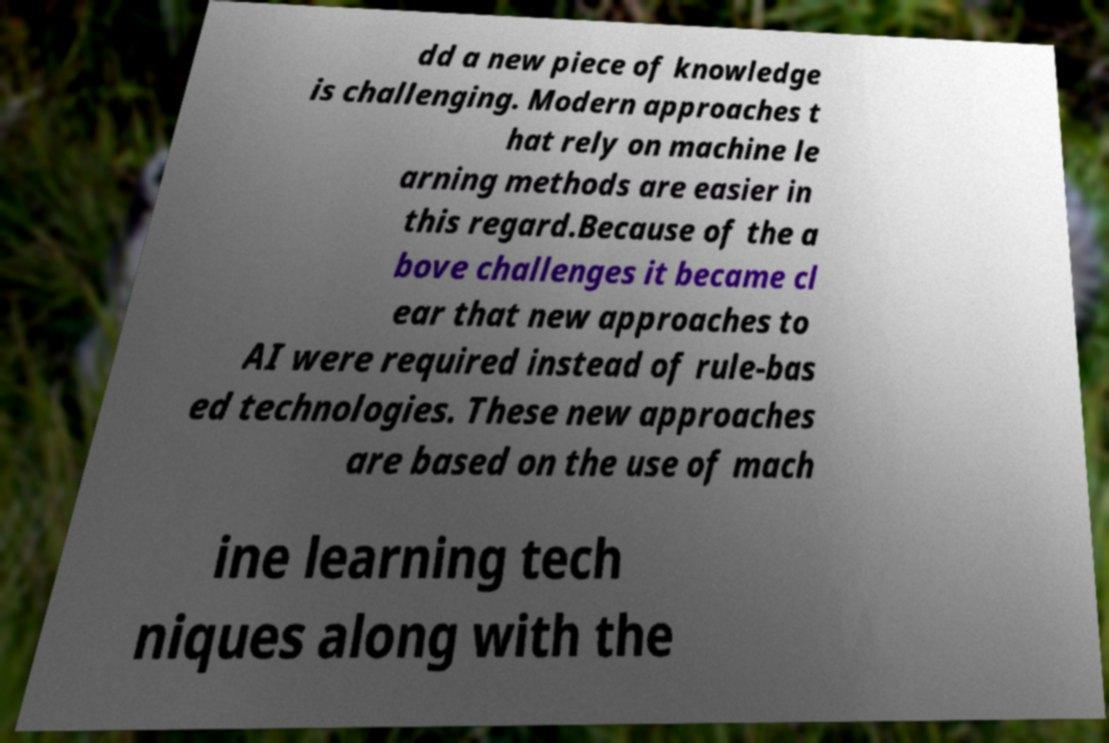There's text embedded in this image that I need extracted. Can you transcribe it verbatim? dd a new piece of knowledge is challenging. Modern approaches t hat rely on machine le arning methods are easier in this regard.Because of the a bove challenges it became cl ear that new approaches to AI were required instead of rule-bas ed technologies. These new approaches are based on the use of mach ine learning tech niques along with the 